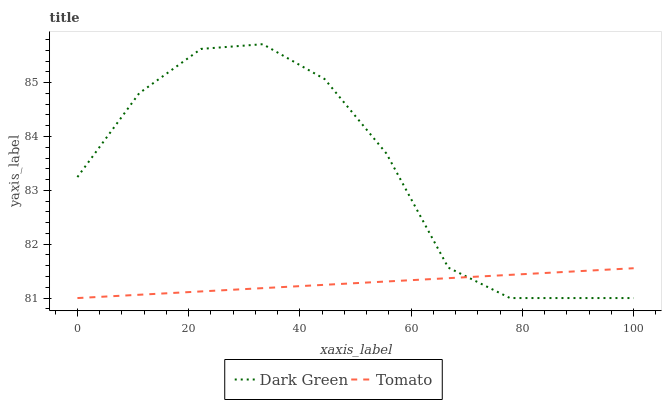Does Tomato have the minimum area under the curve?
Answer yes or no. Yes. Does Dark Green have the maximum area under the curve?
Answer yes or no. Yes. Does Dark Green have the minimum area under the curve?
Answer yes or no. No. Is Tomato the smoothest?
Answer yes or no. Yes. Is Dark Green the roughest?
Answer yes or no. Yes. Is Dark Green the smoothest?
Answer yes or no. No. Does Tomato have the lowest value?
Answer yes or no. Yes. Does Dark Green have the highest value?
Answer yes or no. Yes. Does Tomato intersect Dark Green?
Answer yes or no. Yes. Is Tomato less than Dark Green?
Answer yes or no. No. Is Tomato greater than Dark Green?
Answer yes or no. No. 